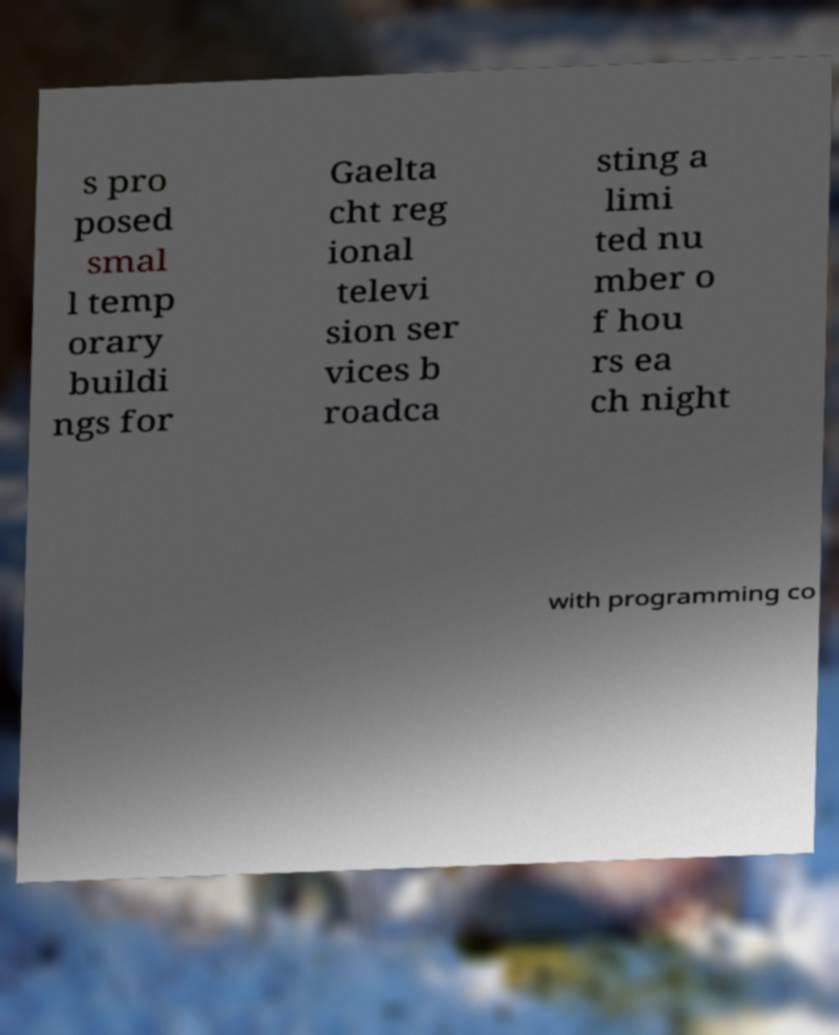I need the written content from this picture converted into text. Can you do that? s pro posed smal l temp orary buildi ngs for Gaelta cht reg ional televi sion ser vices b roadca sting a limi ted nu mber o f hou rs ea ch night with programming co 